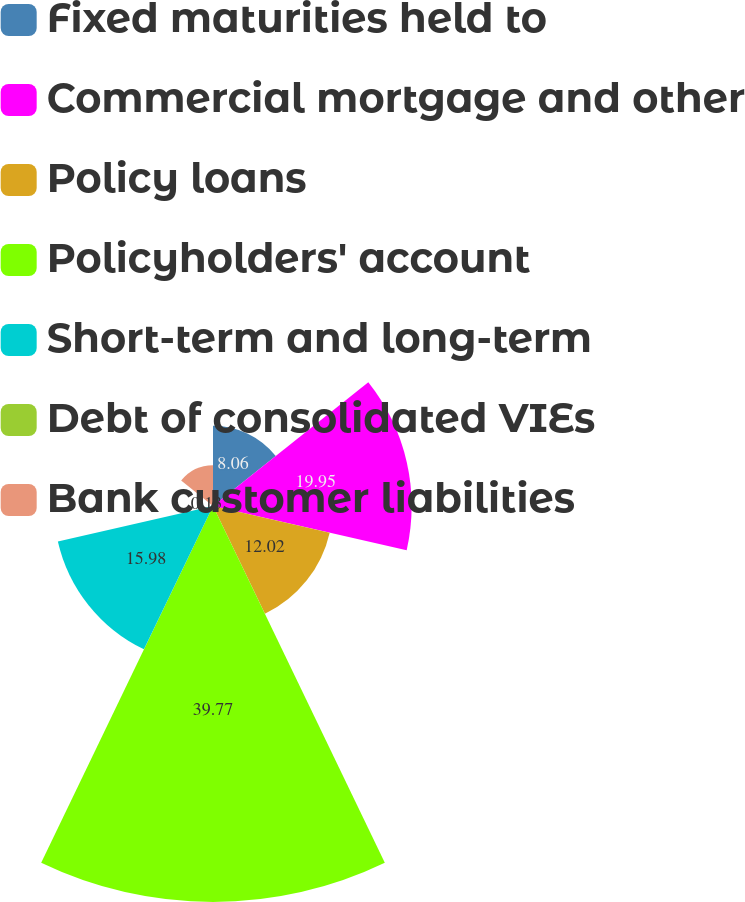<chart> <loc_0><loc_0><loc_500><loc_500><pie_chart><fcel>Fixed maturities held to<fcel>Commercial mortgage and other<fcel>Policy loans<fcel>Policyholders' account<fcel>Short-term and long-term<fcel>Debt of consolidated VIEs<fcel>Bank customer liabilities<nl><fcel>8.06%<fcel>19.95%<fcel>12.02%<fcel>39.77%<fcel>15.98%<fcel>0.13%<fcel>4.09%<nl></chart> 